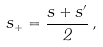Convert formula to latex. <formula><loc_0><loc_0><loc_500><loc_500>s _ { + } = \frac { s + s ^ { \prime } } { 2 } \, ,</formula> 